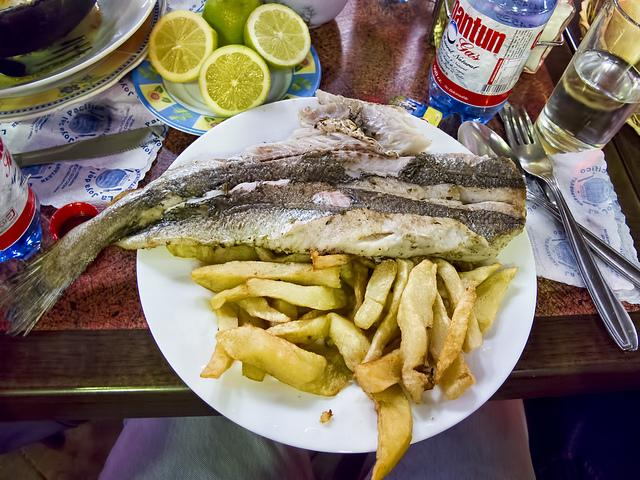What country's citizens are famous for eating this food combination? Please explain your reasoning. england. Fish and chips are very common in the united kingdom. 